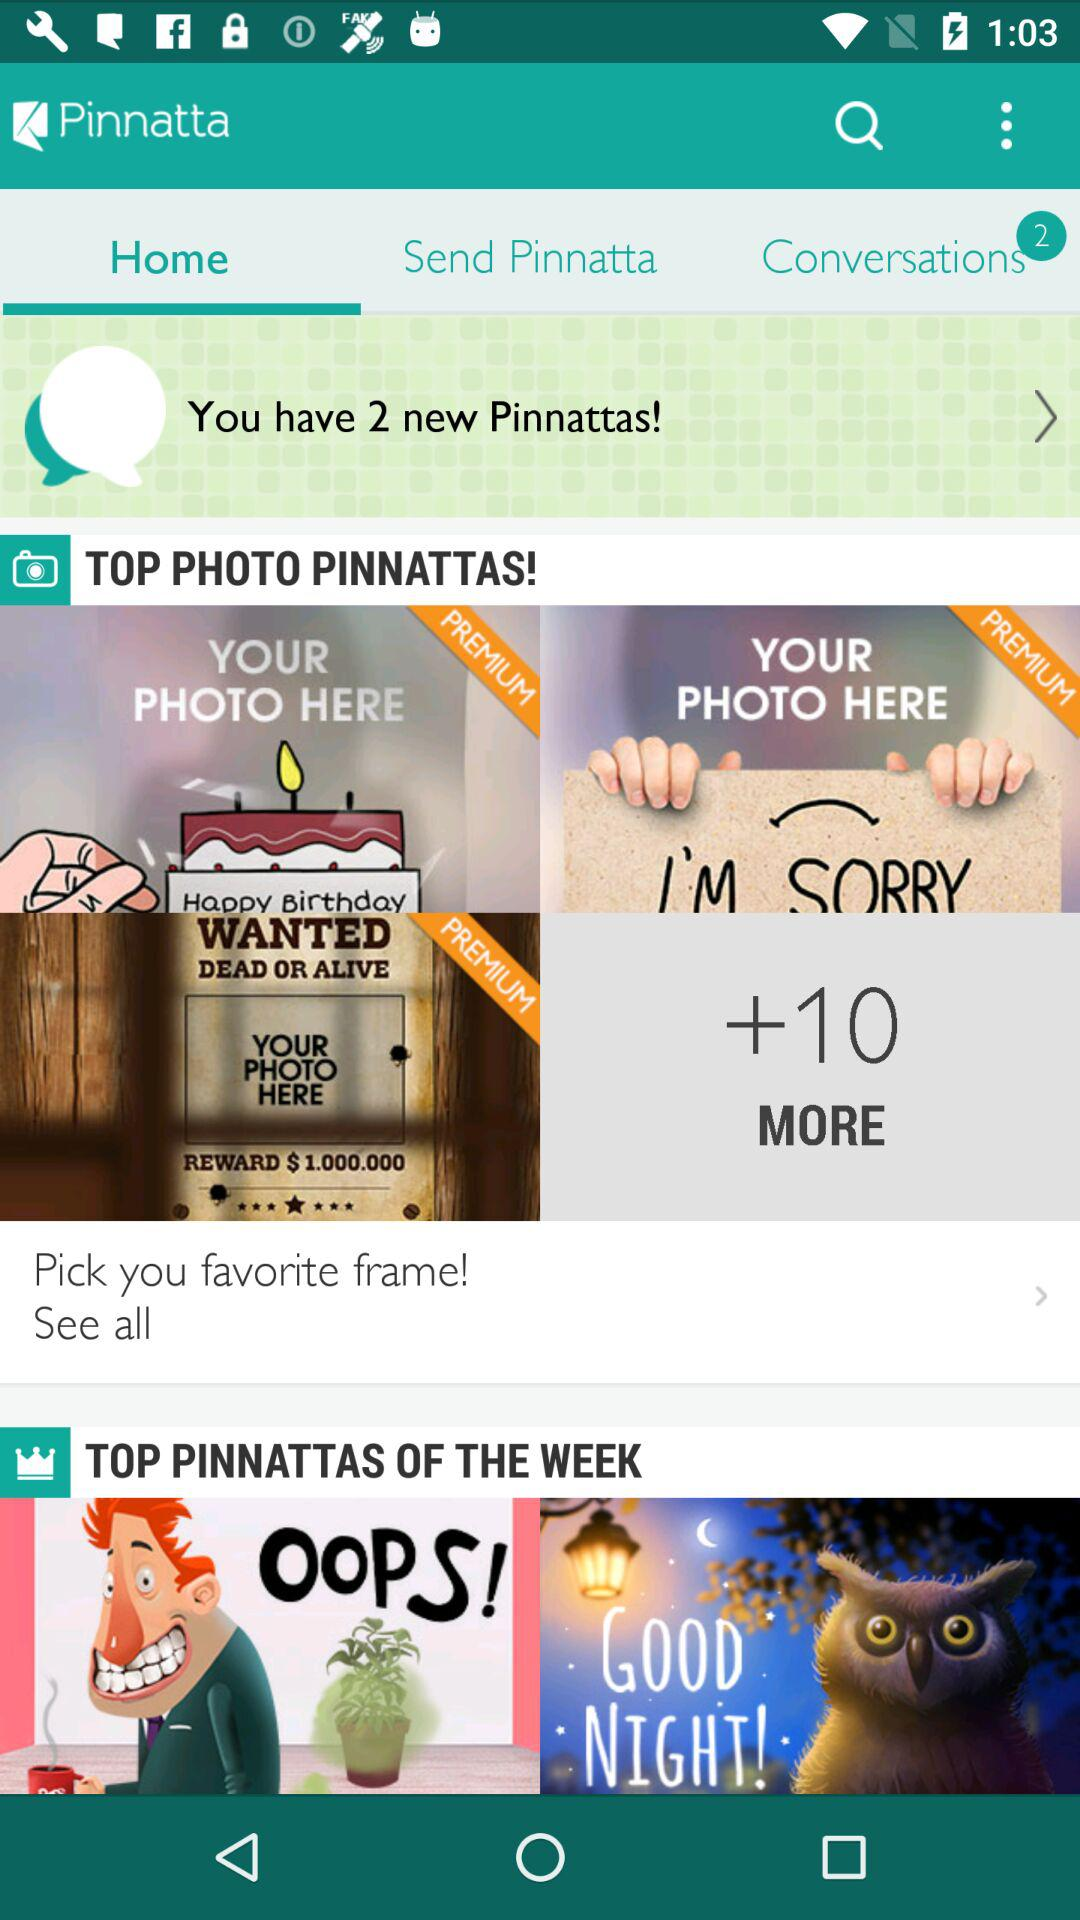How many more "Pinnatta" photos are there? There are 10 more "Pinnatta" photos. 